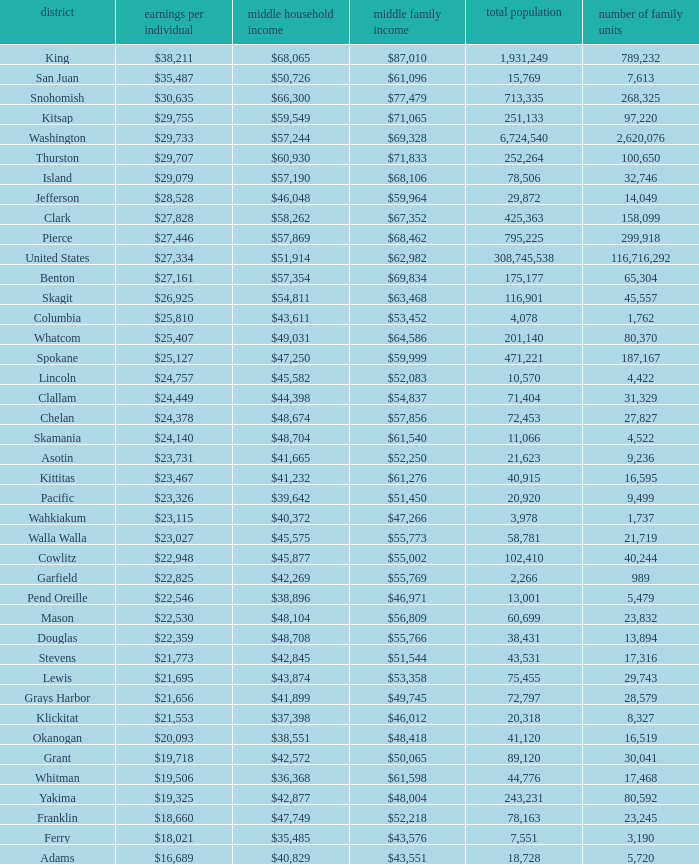How much is per capita income when median household income is $42,845? $21,773. Give me the full table as a dictionary. {'header': ['district', 'earnings per individual', 'middle household income', 'middle family income', 'total population', 'number of family units'], 'rows': [['King', '$38,211', '$68,065', '$87,010', '1,931,249', '789,232'], ['San Juan', '$35,487', '$50,726', '$61,096', '15,769', '7,613'], ['Snohomish', '$30,635', '$66,300', '$77,479', '713,335', '268,325'], ['Kitsap', '$29,755', '$59,549', '$71,065', '251,133', '97,220'], ['Washington', '$29,733', '$57,244', '$69,328', '6,724,540', '2,620,076'], ['Thurston', '$29,707', '$60,930', '$71,833', '252,264', '100,650'], ['Island', '$29,079', '$57,190', '$68,106', '78,506', '32,746'], ['Jefferson', '$28,528', '$46,048', '$59,964', '29,872', '14,049'], ['Clark', '$27,828', '$58,262', '$67,352', '425,363', '158,099'], ['Pierce', '$27,446', '$57,869', '$68,462', '795,225', '299,918'], ['United States', '$27,334', '$51,914', '$62,982', '308,745,538', '116,716,292'], ['Benton', '$27,161', '$57,354', '$69,834', '175,177', '65,304'], ['Skagit', '$26,925', '$54,811', '$63,468', '116,901', '45,557'], ['Columbia', '$25,810', '$43,611', '$53,452', '4,078', '1,762'], ['Whatcom', '$25,407', '$49,031', '$64,586', '201,140', '80,370'], ['Spokane', '$25,127', '$47,250', '$59,999', '471,221', '187,167'], ['Lincoln', '$24,757', '$45,582', '$52,083', '10,570', '4,422'], ['Clallam', '$24,449', '$44,398', '$54,837', '71,404', '31,329'], ['Chelan', '$24,378', '$48,674', '$57,856', '72,453', '27,827'], ['Skamania', '$24,140', '$48,704', '$61,540', '11,066', '4,522'], ['Asotin', '$23,731', '$41,665', '$52,250', '21,623', '9,236'], ['Kittitas', '$23,467', '$41,232', '$61,276', '40,915', '16,595'], ['Pacific', '$23,326', '$39,642', '$51,450', '20,920', '9,499'], ['Wahkiakum', '$23,115', '$40,372', '$47,266', '3,978', '1,737'], ['Walla Walla', '$23,027', '$45,575', '$55,773', '58,781', '21,719'], ['Cowlitz', '$22,948', '$45,877', '$55,002', '102,410', '40,244'], ['Garfield', '$22,825', '$42,269', '$55,769', '2,266', '989'], ['Pend Oreille', '$22,546', '$38,896', '$46,971', '13,001', '5,479'], ['Mason', '$22,530', '$48,104', '$56,809', '60,699', '23,832'], ['Douglas', '$22,359', '$48,708', '$55,766', '38,431', '13,894'], ['Stevens', '$21,773', '$42,845', '$51,544', '43,531', '17,316'], ['Lewis', '$21,695', '$43,874', '$53,358', '75,455', '29,743'], ['Grays Harbor', '$21,656', '$41,899', '$49,745', '72,797', '28,579'], ['Klickitat', '$21,553', '$37,398', '$46,012', '20,318', '8,327'], ['Okanogan', '$20,093', '$38,551', '$48,418', '41,120', '16,519'], ['Grant', '$19,718', '$42,572', '$50,065', '89,120', '30,041'], ['Whitman', '$19,506', '$36,368', '$61,598', '44,776', '17,468'], ['Yakima', '$19,325', '$42,877', '$48,004', '243,231', '80,592'], ['Franklin', '$18,660', '$47,749', '$52,218', '78,163', '23,245'], ['Ferry', '$18,021', '$35,485', '$43,576', '7,551', '3,190'], ['Adams', '$16,689', '$40,829', '$43,551', '18,728', '5,720']]} 